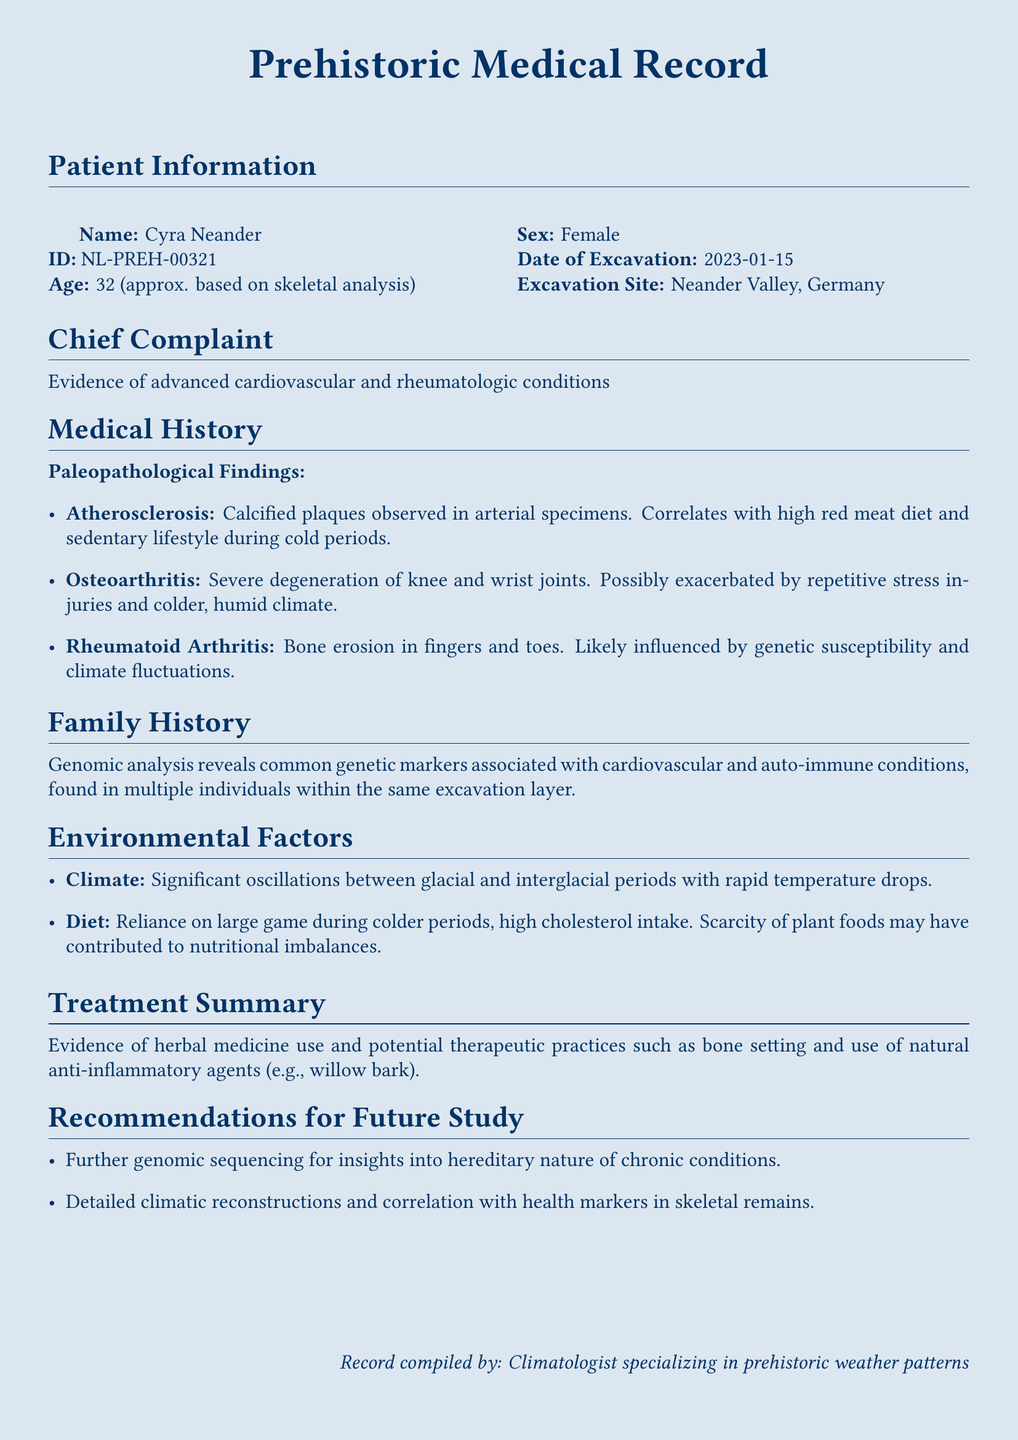What is the patient's age? The patient's age is based on skeletal analysis, indicated as 32 years old.
Answer: 32 What is the excavation date? The excavation date is specifically noted in the document.
Answer: 2023-01-15 What condition shows calcified plaques? The condition indicated in the medical history with calcified plaques is mentioned.
Answer: Atherosclerosis What type of arthritis is related to bone erosion in fingers and toes? The document specifies the type of arthritis associated with this bone erosion.
Answer: Rheumatoid Arthritis What climatic phenomenon is noted as influencing the patient's conditions? Significant oscillations between glacial and interglacial periods are mentioned as environmental factors.
Answer: Climate What was the diet during colder periods according to the document? The document notes the diet reliance on large game during colder periods.
Answer: Reliance on large game What are the recommended further studies? The future study recommendations include several investigative directions.
Answer: Genomic sequencing and climatic reconstructions What evidence suggests the use of herbal medicine? The treatment summary mentions the use of herbal medicine for therapeutic practices.
Answer: Herbal medicine What is the sex of the patient? The patient's sex is explicitly stated in the document.
Answer: Female 